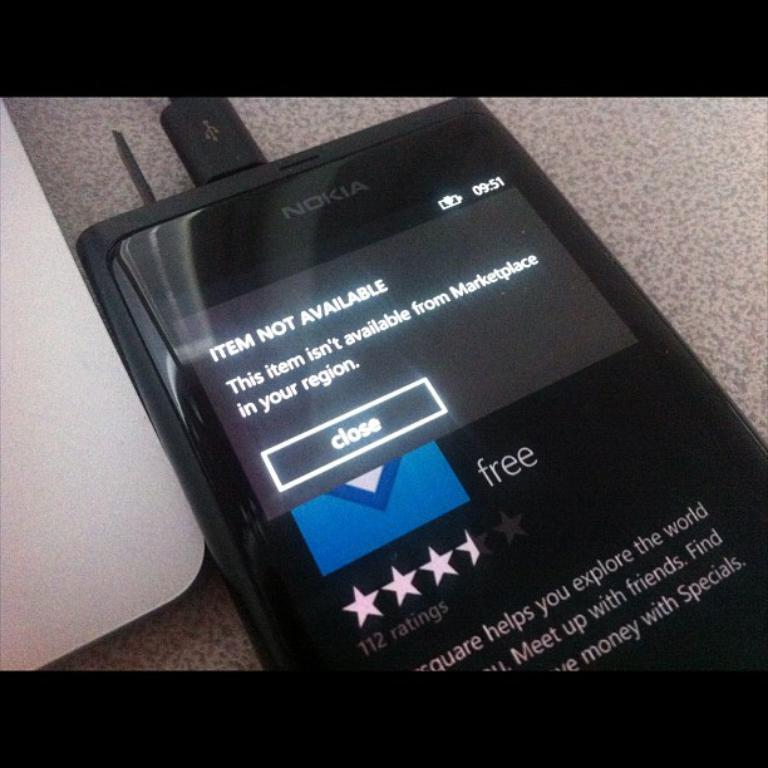<image>
Write a terse but informative summary of the picture. A nokia phone with an item not available notification on the screen 